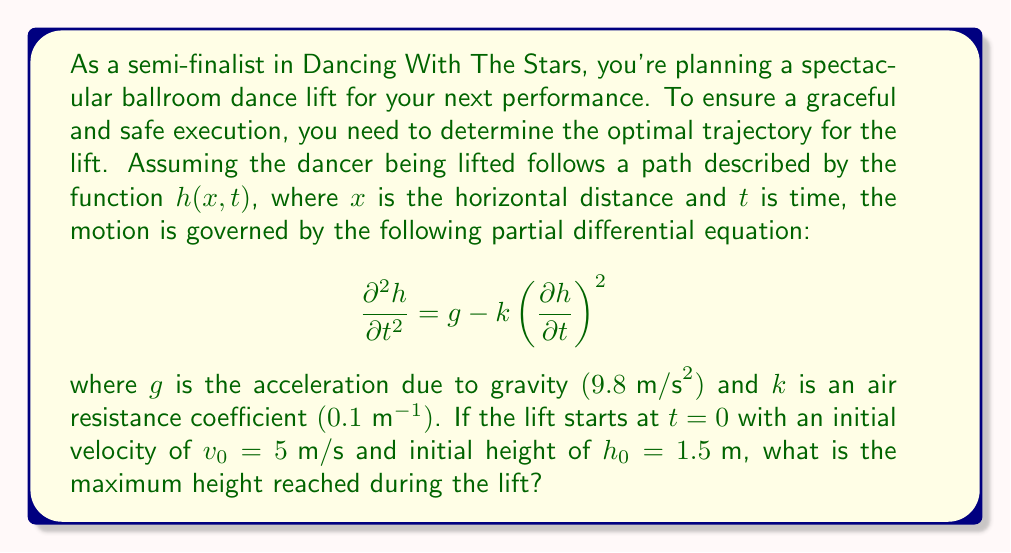Help me with this question. To solve this problem, we need to analyze the given partial differential equation (PDE) and apply the initial conditions. Let's break it down step by step:

1) The given PDE is:
   $$\frac{\partial^2h}{\partial t^2} = g - k\left(\frac{\partial h}{\partial t}\right)^2$$

2) This equation describes the vertical motion of the lifted dancer. The term $\frac{\partial^2h}{\partial t^2}$ represents the vertical acceleration, $g$ is the acceleration due to gravity, and $k\left(\frac{\partial h}{\partial t}\right)^2$ represents air resistance.

3) To find the maximum height, we need to determine when the vertical velocity $\frac{\partial h}{\partial t}$ becomes zero. At this point, the dancer reaches the peak of the lift.

4) Let's denote $\frac{\partial h}{\partial t}$ as $v(t)$. Then our equation becomes:
   $$\frac{dv}{dt} = g - kv^2$$

5) This is a separable ordinary differential equation. We can solve it as follows:
   $$\int \frac{dv}{g - kv^2} = \int dt$$

6) Integrating both sides:
   $$-\frac{1}{\sqrt{gk}} \tanh^{-1}\left(\sqrt{\frac{k}{g}}v\right) = t + C$$

7) Using the initial condition $v(0) = v_0 = 5 \text{ m/s}$, we can find C:
   $$C = -\frac{1}{\sqrt{gk}} \tanh^{-1}\left(\sqrt{\frac{k}{g}}v_0\right)$$

8) The velocity as a function of time is then:
   $$v(t) = \sqrt{\frac{g}{k}} \tanh\left(\sqrt{gk}(C - t)\right)$$

9) To find the maximum height, we need to integrate $v(t)$ from $t=0$ to the time when $v(t)=0$. Let's call this time $t_{max}$:
   $$t_{max} = C = -\frac{1}{\sqrt{gk}} \tanh^{-1}\left(\sqrt{\frac{k}{g}}v_0\right)$$

10) The change in height is:
    $$\Delta h = \int_0^{t_{max}} v(t) dt = \frac{g}{k} \ln\left(\cosh\left(\sqrt{gk}t_{max}\right)\right)$$

11) Therefore, the maximum height is:
    $$h_{max} = h_0 + \frac{g}{k} \ln\left(\cosh\left(\sqrt{gk}t_{max}\right)\right)$$

12) Plugging in the values:
    $g = 9.8 \text{ m/s}^2$, $k = 0.1 \text{ m}^{-1}$, $v_0 = 5 \text{ m/s}$, $h_0 = 1.5 \text{ m}$

    We get: $h_{max} \approx 3.93 \text{ m}$
Answer: The maximum height reached during the lift is approximately 3.93 meters. 